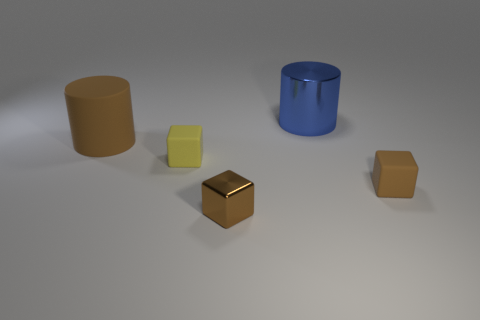Subtract 1 blocks. How many blocks are left? 2 Add 4 rubber cylinders. How many objects exist? 9 Subtract all cylinders. How many objects are left? 3 Subtract all rubber cylinders. Subtract all metallic cubes. How many objects are left? 3 Add 1 tiny brown blocks. How many tiny brown blocks are left? 3 Add 1 brown cylinders. How many brown cylinders exist? 2 Subtract 0 gray blocks. How many objects are left? 5 